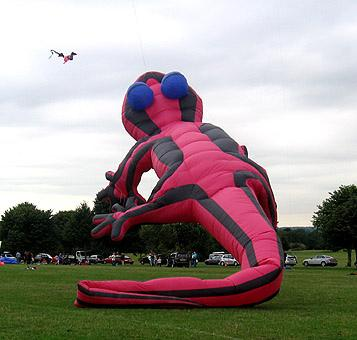What reptile is depicted in the extra large kite? lizard 